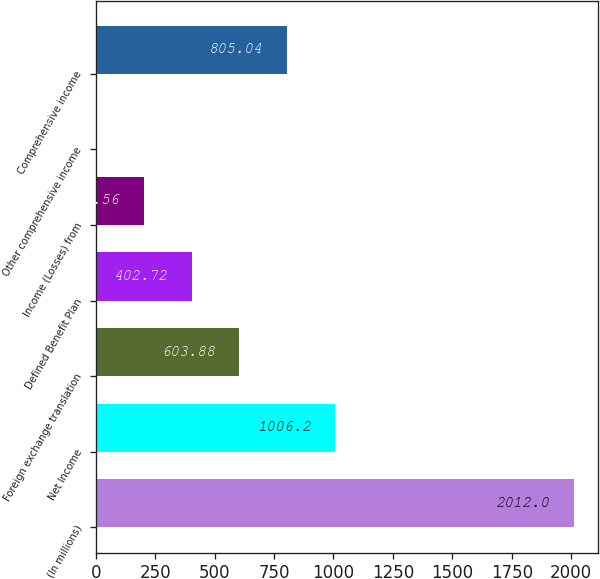Convert chart to OTSL. <chart><loc_0><loc_0><loc_500><loc_500><bar_chart><fcel>(In millions)<fcel>Net Income<fcel>Foreign exchange translation<fcel>Defined Benefit Plan<fcel>Income (Losses) from<fcel>Other comprehensive income<fcel>Comprehensive income<nl><fcel>2012<fcel>1006.2<fcel>603.88<fcel>402.72<fcel>201.56<fcel>0.4<fcel>805.04<nl></chart> 